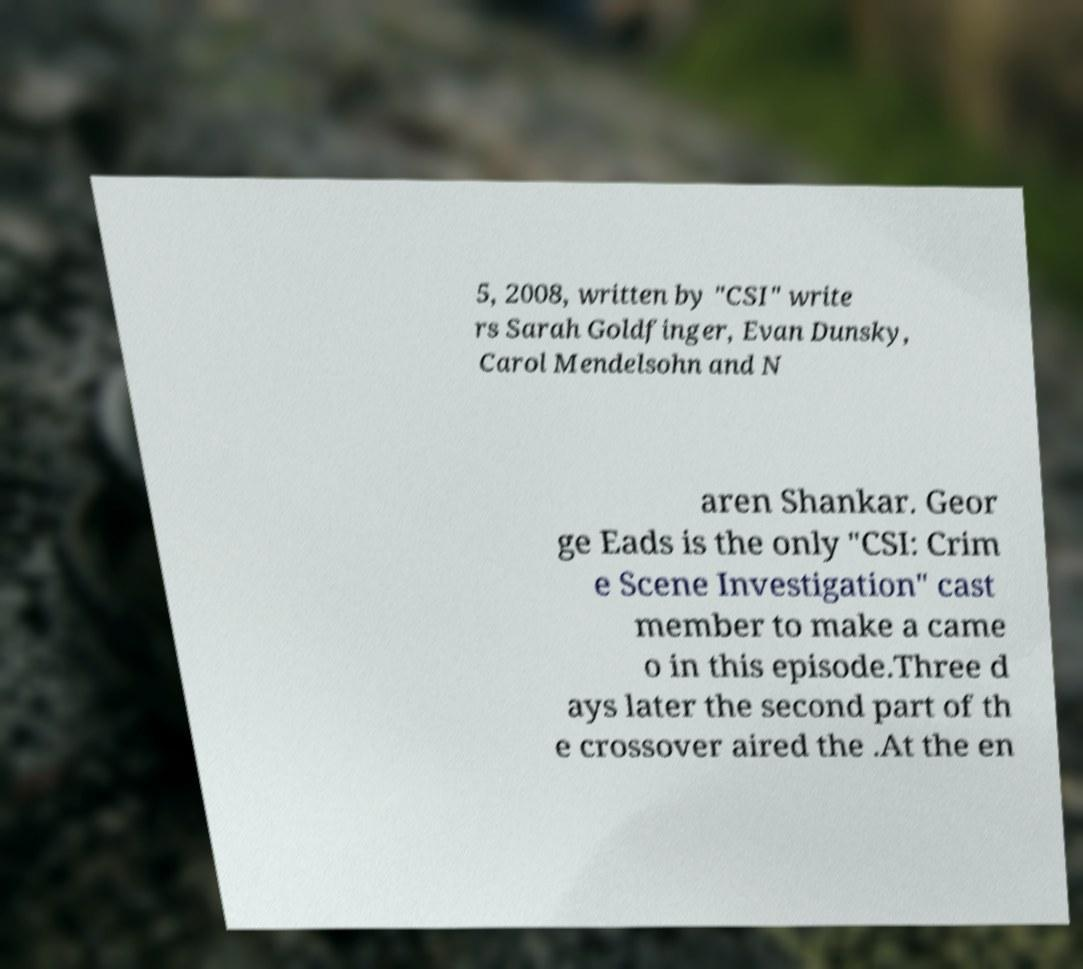Can you read and provide the text displayed in the image?This photo seems to have some interesting text. Can you extract and type it out for me? 5, 2008, written by "CSI" write rs Sarah Goldfinger, Evan Dunsky, Carol Mendelsohn and N aren Shankar. Geor ge Eads is the only "CSI: Crim e Scene Investigation" cast member to make a came o in this episode.Three d ays later the second part of th e crossover aired the .At the en 